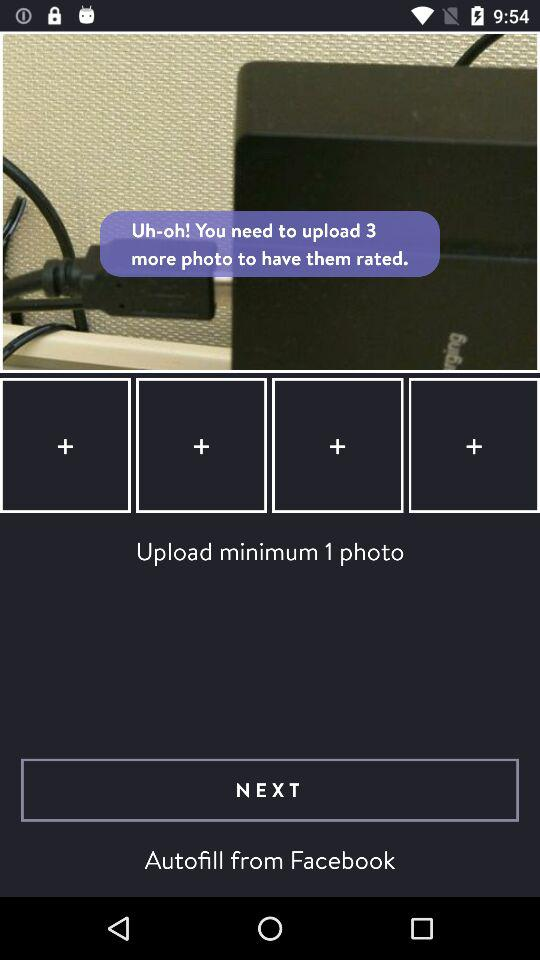What is the user's name?
When the provided information is insufficient, respond with <no answer>. <no answer> 